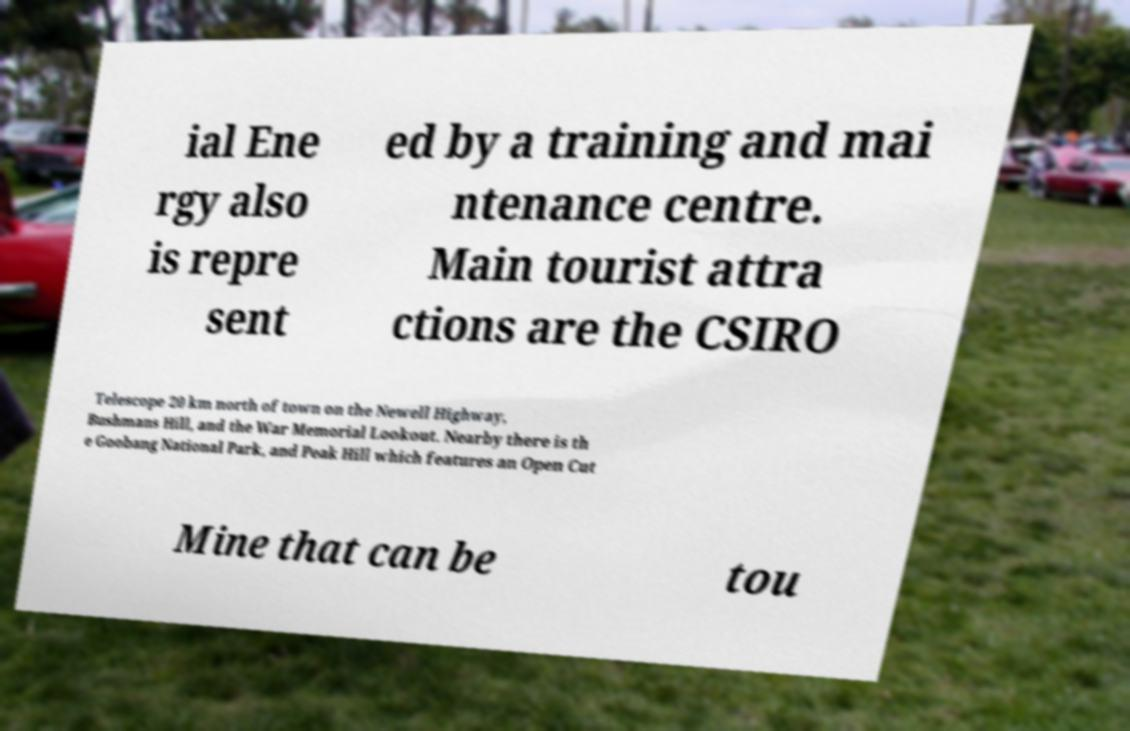I need the written content from this picture converted into text. Can you do that? ial Ene rgy also is repre sent ed by a training and mai ntenance centre. Main tourist attra ctions are the CSIRO Telescope 20 km north of town on the Newell Highway, Bushmans Hill, and the War Memorial Lookout. Nearby there is th e Goobang National Park, and Peak Hill which features an Open Cut Mine that can be tou 